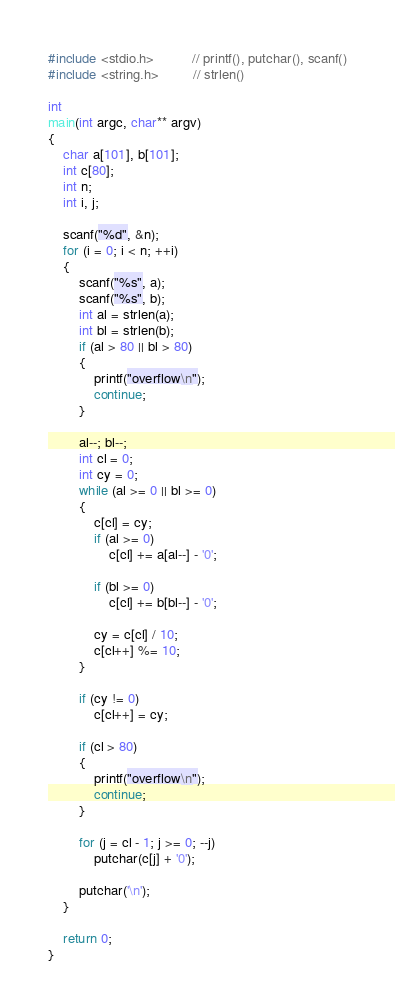Convert code to text. <code><loc_0><loc_0><loc_500><loc_500><_C_>#include <stdio.h>          // printf(), putchar(), scanf()
#include <string.h>         // strlen()

int
main(int argc, char** argv)
{
	char a[101], b[101];
	int c[80];
	int n;
	int i, j;

	scanf("%d", &n);
	for (i = 0; i < n; ++i)
	{
		scanf("%s", a);
		scanf("%s", b);
		int al = strlen(a);
		int bl = strlen(b);
		if (al > 80 || bl > 80)
		{
			printf("overflow\n");
			continue;
		}

		al--; bl--;
		int cl = 0;
		int cy = 0;
		while (al >= 0 || bl >= 0)
		{
			c[cl] = cy;
			if (al >= 0)
				c[cl] += a[al--] - '0';

			if (bl >= 0)
				c[cl] += b[bl--] - '0';

			cy = c[cl] / 10;
			c[cl++] %= 10;
		}

		if (cy != 0)
			c[cl++] = cy;

		if (cl > 80)
		{
			printf("overflow\n");
			continue;
		}

		for (j = cl - 1; j >= 0; --j)
			putchar(c[j] + '0');

		putchar('\n');
	}

	return 0;
}</code> 